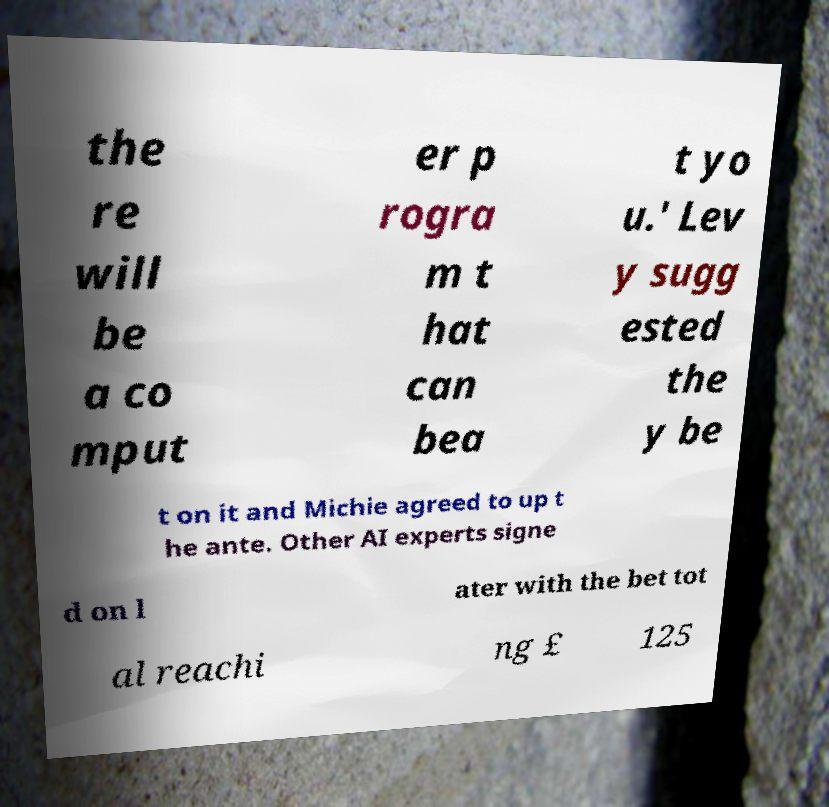Can you accurately transcribe the text from the provided image for me? the re will be a co mput er p rogra m t hat can bea t yo u.' Lev y sugg ested the y be t on it and Michie agreed to up t he ante. Other AI experts signe d on l ater with the bet tot al reachi ng £ 125 